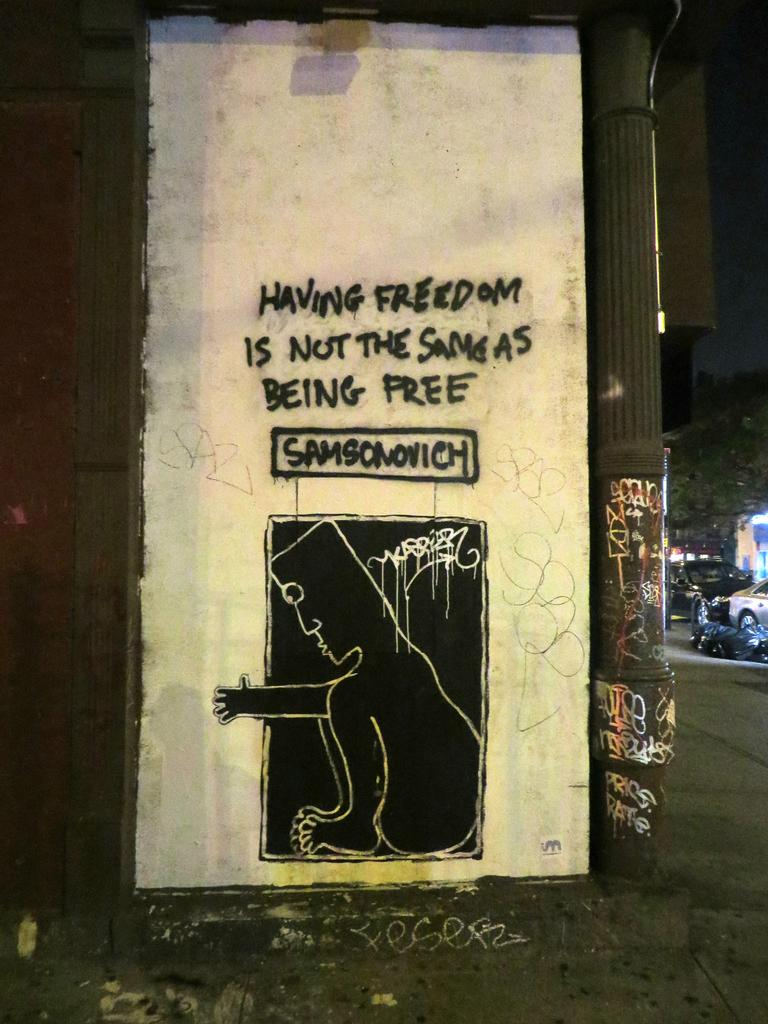<image>
Relay a brief, clear account of the picture shown. Graffiti on a building states that having freedom doesn't equal the same thing as being free. 